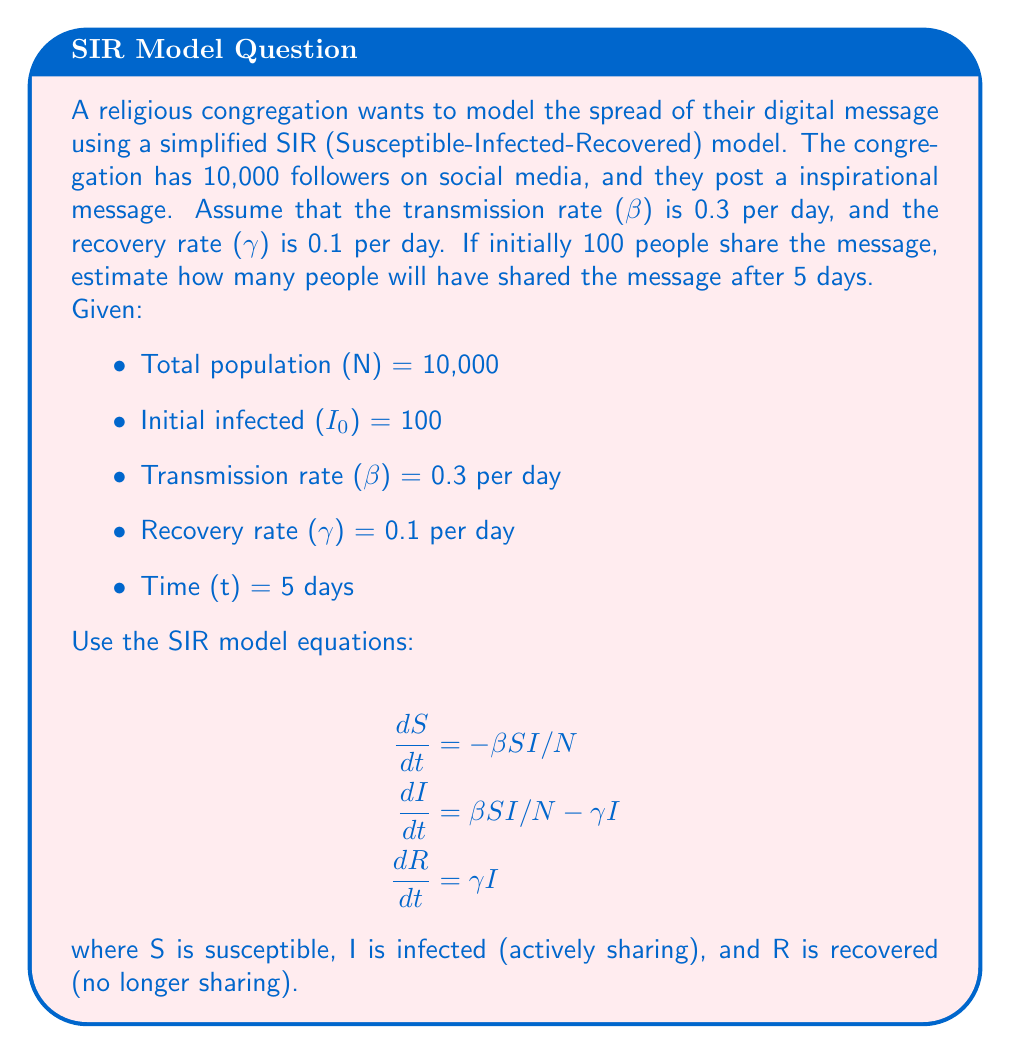Could you help me with this problem? To solve this problem, we'll use a simplified approach to the SIR model, focusing on the "infected" (actively sharing) population. We'll use the exponential growth approximation for the early stages of message spread.

1. Calculate the basic reproduction number (R₀):
   $$R_0 = \frac{\beta}{\gamma} = \frac{0.3}{0.1} = 3$$

2. Use the exponential growth equation:
   $$I(t) = I_0 e^{r t}$$
   where r is the growth rate, given by:
   $$r = (\beta - \gamma) = 0.3 - 0.1 = 0.2$$

3. Substitute the values into the exponential growth equation:
   $$I(5) = 100 \cdot e^{0.2 \cdot 5}$$

4. Calculate the result:
   $$I(5) = 100 \cdot e^1 = 100 \cdot 2.71828... \approx 271.828$$

5. Round to the nearest whole number, as we can't have fractional people:
   $$I(5) \approx 272$$

This simplified model estimates that after 5 days, approximately 272 people will have shared the message. 

Note: This is a simplification and doesn't account for the depletion of the susceptible population or the full dynamics of the SIR model. In reality, the spread might be slower as the susceptible population decreases.
Answer: Approximately 272 people will have shared the message after 5 days. 